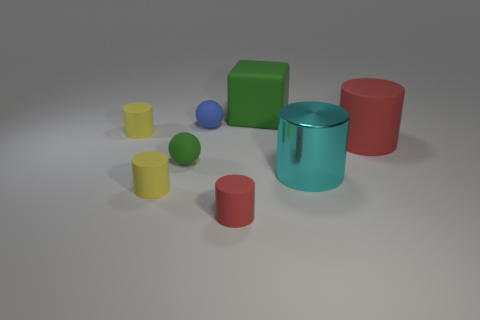Is there a large metallic thing that has the same color as the large block?
Provide a short and direct response. No. The green block that is the same material as the blue sphere is what size?
Offer a terse response. Large. There is a green matte thing left of the red rubber object left of the large matte thing that is right of the big green rubber object; what shape is it?
Your answer should be compact. Sphere. The other object that is the same shape as the blue object is what size?
Ensure brevity in your answer.  Small. How big is the cylinder that is both behind the large cyan metallic object and to the right of the small blue thing?
Your response must be concise. Large. There is a small rubber thing that is the same color as the large matte block; what shape is it?
Offer a terse response. Sphere. The big metallic thing has what color?
Ensure brevity in your answer.  Cyan. What is the size of the red cylinder that is on the left side of the big green cube?
Offer a terse response. Small. There is a green thing on the right side of the sphere that is in front of the small blue sphere; how many matte things are in front of it?
Keep it short and to the point. 6. What is the color of the small rubber cylinder left of the yellow thing that is in front of the big red matte cylinder?
Keep it short and to the point. Yellow. 